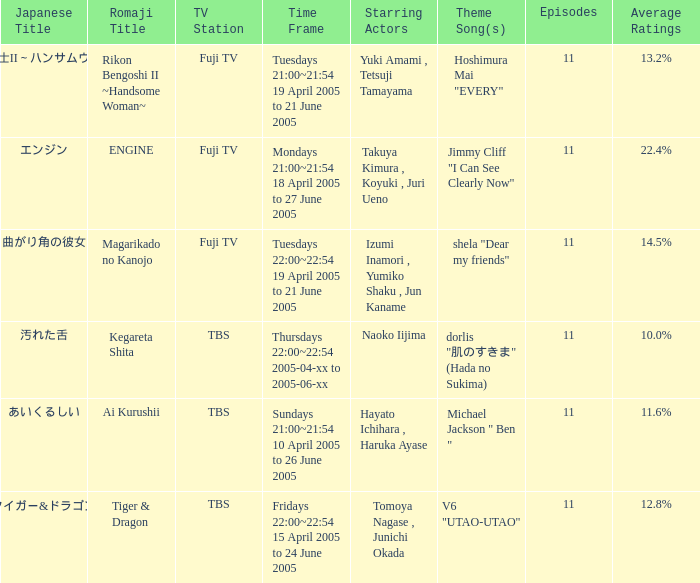Could you parse the entire table? {'header': ['Japanese Title', 'Romaji Title', 'TV Station', 'Time Frame', 'Starring Actors', 'Theme Song(s)', 'Episodes', 'Average Ratings'], 'rows': [['離婚弁護士II～ハンサムウーマン～', 'Rikon Bengoshi II ~Handsome Woman~', 'Fuji TV', 'Tuesdays 21:00~21:54 19 April 2005 to 21 June 2005', 'Yuki Amami , Tetsuji Tamayama', 'Hoshimura Mai "EVERY"', '11', '13.2%'], ['エンジン', 'ENGINE', 'Fuji TV', 'Mondays 21:00~21:54 18 April 2005 to 27 June 2005', 'Takuya Kimura , Koyuki , Juri Ueno', 'Jimmy Cliff "I Can See Clearly Now"', '11', '22.4%'], ['曲がり角の彼女', 'Magarikado no Kanojo', 'Fuji TV', 'Tuesdays 22:00~22:54 19 April 2005 to 21 June 2005', 'Izumi Inamori , Yumiko Shaku , Jun Kaname', 'shela "Dear my friends"', '11', '14.5%'], ['汚れた舌', 'Kegareta Shita', 'TBS', 'Thursdays 22:00~22:54 2005-04-xx to 2005-06-xx', 'Naoko Iijima', 'dorlis "肌のすきま" (Hada no Sukima)', '11', '10.0%'], ['あいくるしい', 'Ai Kurushii', 'TBS', 'Sundays 21:00~21:54 10 April 2005 to 26 June 2005', 'Hayato Ichihara , Haruka Ayase', 'Michael Jackson " Ben "', '11', '11.6%'], ['タイガー&ドラゴン', 'Tiger & Dragon', 'TBS', 'Fridays 22:00~22:54 15 April 2005 to 24 June 2005', 'Tomoya Nagase , Junichi Okada', 'V6 "UTAO-UTAO"', '11', '12.8%']]} What is the title with an average rating of 22.4%? ENGINE. 